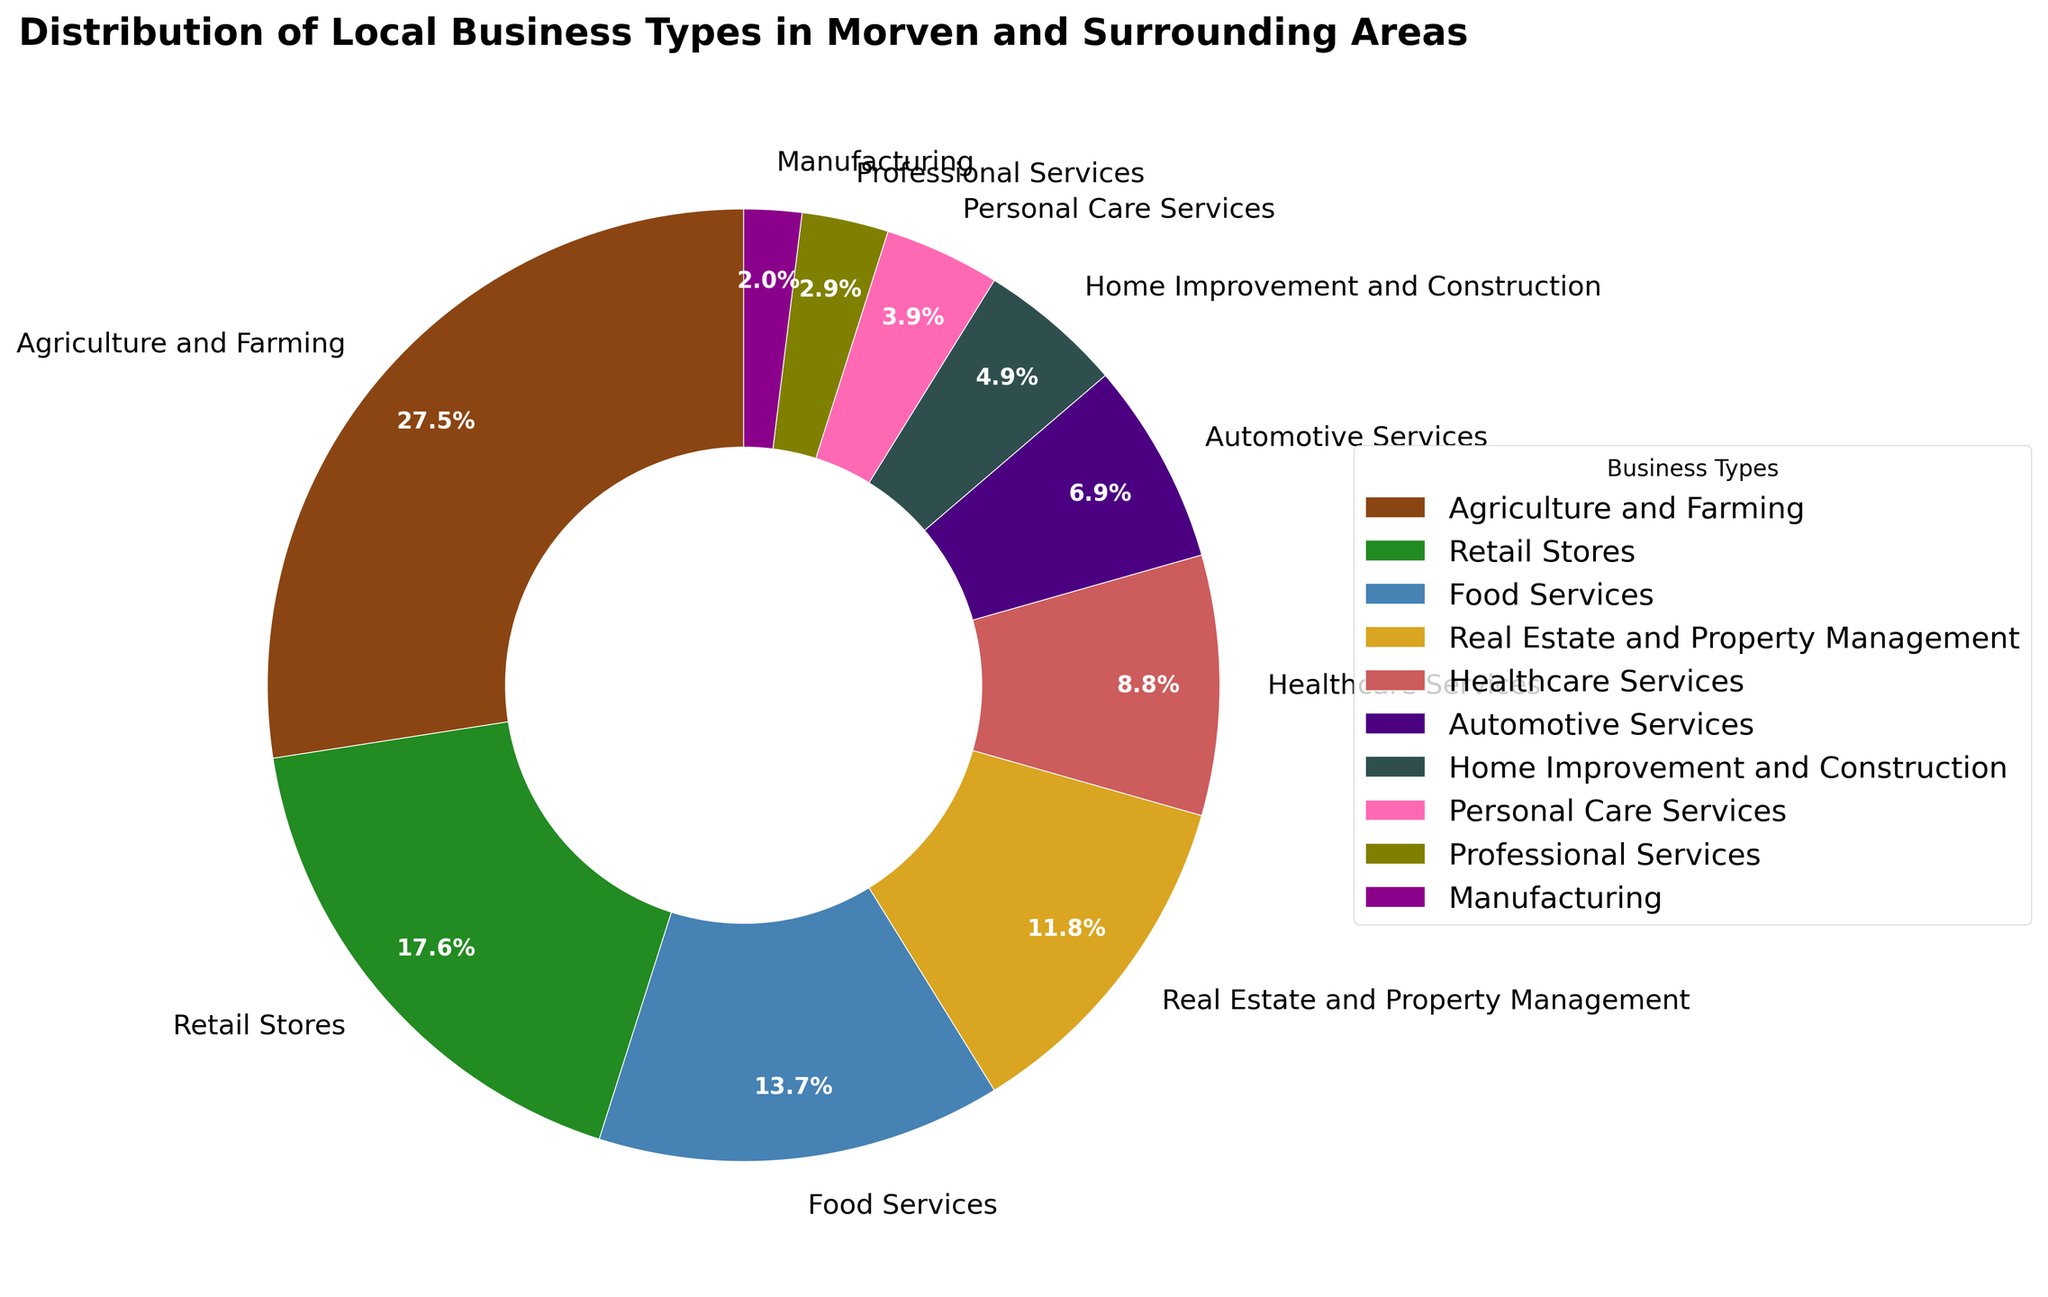Which business type has the highest percentage? The Agriculture and Farming sector has the highest percentage which is 28%, as visually evident from the largest wedge in the pie chart.
Answer: Agriculture and Farming Which business type has the smallest percentage? The Manufacturing sector has the smallest percentage which is 2%, as visually evident from the smallest wedge in the pie chart.
Answer: Manufacturing What is the combined percentage of Agriculture and Farming, and Food Services? Sum the percentages of Agriculture and Farming (28%) and Food Services (14%), which is 28 + 14 = 42%.
Answer: 42% How does the percentage of Retail Stores compare to Real Estate and Property Management? The percentage for Retail Stores is 18%, whereas Real Estate and Property Management is 12%. Therefore, Retail Stores are higher by a difference of 18 - 12 = 6%.
Answer: Retail Stores is higher by 6% What is the cumulative percentage of sectors with less than 10% each? Add the percentages of sectors with less than 10%, which are Healthcare Services (9%), Automotive Services (7%), Home Improvement and Construction (5%), Personal Care Services (4%), Professional Services (3%), and Manufacturing (2%). The total is 9 + 7 + 5 + 4 + 3 + 2 = 30%.
Answer: 30% Which sectors collectively make up more than half (greater than 50%) of the pie chart? Sum the percentages starting from the highest until it exceeds 50%. Agriculture and Farming (28%), Retail Stores (18%), and Food Services (14%) together yield 28 + 18 + 14 = 60%, which is greater than 50%.
Answer: Agriculture and Farming, Retail Stores, and Food Services What percentages are represented by wedges in shades of blue? From the description, the color for 'Home Improvement and Construction' is likely blue, accounting for 5%. Simplifying, there is only one sector listed and it makes up 5% of the pie chart.
Answer: 5% Is the percentage covered by Professional Services greater than the sector with the green wedge? The percentage of Professional Services is 3% and the green wedge corresponds to Retail Stores which is 18%. Hence, Professional Services is not greater than Retail Stores.
Answer: No What is the visual difference between Automotive Services and Home Improvement and Construction sectors? Evaluate the visual wedge sizes in the pie chart. Automotive Services represent 7% and Home Improvement and Construction is 5%. Visually, Automotive Services has a slightly larger wedge than Home Improvement and Construction.
Answer: Automotive Services is larger Which sector is highlighted in pink and what is its percentage? The description lists 'Personal Care Services' promptly suited for pink, which contributes 4% as seen in the pie chart.
Answer: Personal Care Services, 4% 